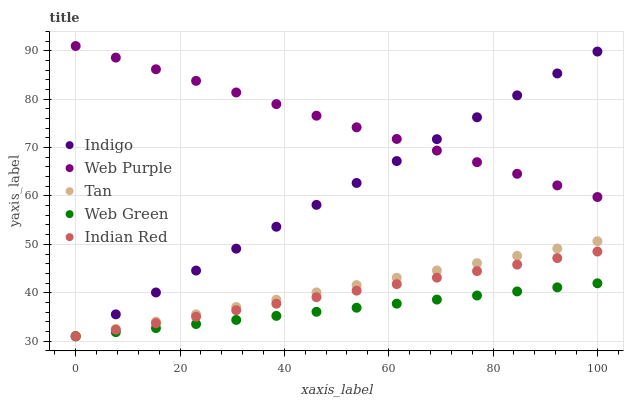Does Web Green have the minimum area under the curve?
Answer yes or no. Yes. Does Web Purple have the maximum area under the curve?
Answer yes or no. Yes. Does Indigo have the minimum area under the curve?
Answer yes or no. No. Does Indigo have the maximum area under the curve?
Answer yes or no. No. Is Web Green the smoothest?
Answer yes or no. Yes. Is Indigo the roughest?
Answer yes or no. Yes. Is Web Purple the smoothest?
Answer yes or no. No. Is Web Purple the roughest?
Answer yes or no. No. Does Indian Red have the lowest value?
Answer yes or no. Yes. Does Web Purple have the lowest value?
Answer yes or no. No. Does Web Purple have the highest value?
Answer yes or no. Yes. Does Indigo have the highest value?
Answer yes or no. No. Is Indian Red less than Web Purple?
Answer yes or no. Yes. Is Web Purple greater than Tan?
Answer yes or no. Yes. Does Tan intersect Indigo?
Answer yes or no. Yes. Is Tan less than Indigo?
Answer yes or no. No. Is Tan greater than Indigo?
Answer yes or no. No. Does Indian Red intersect Web Purple?
Answer yes or no. No. 